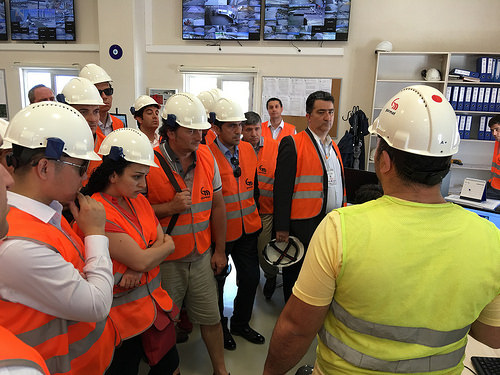<image>
Is there a shelf behind the man? No. The shelf is not behind the man. From this viewpoint, the shelf appears to be positioned elsewhere in the scene. 